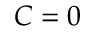<formula> <loc_0><loc_0><loc_500><loc_500>C = 0</formula> 